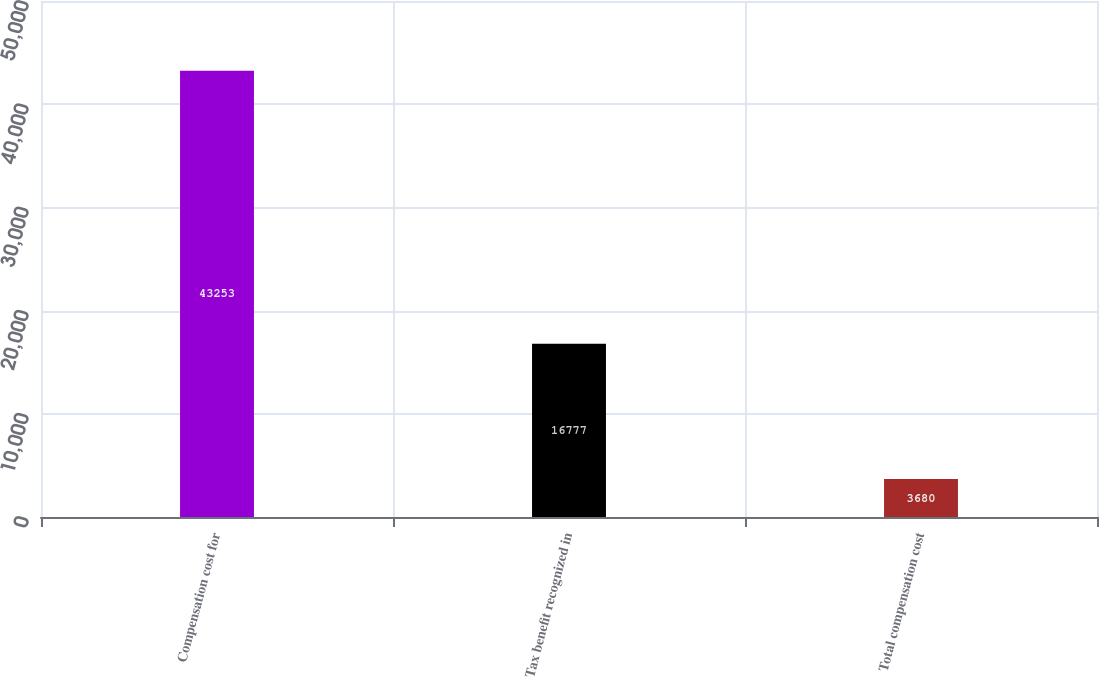Convert chart. <chart><loc_0><loc_0><loc_500><loc_500><bar_chart><fcel>Compensation cost for<fcel>Tax benefit recognized in<fcel>Total compensation cost<nl><fcel>43253<fcel>16777<fcel>3680<nl></chart> 